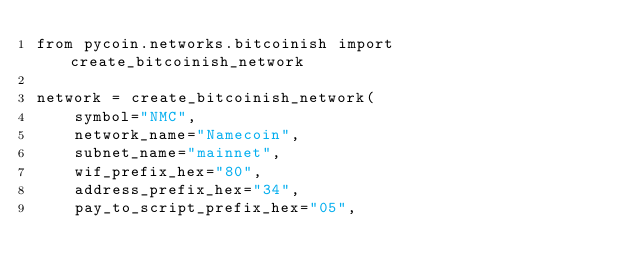<code> <loc_0><loc_0><loc_500><loc_500><_Python_>from pycoin.networks.bitcoinish import create_bitcoinish_network

network = create_bitcoinish_network(
    symbol="NMC",
    network_name="Namecoin",
    subnet_name="mainnet",
    wif_prefix_hex="80",
    address_prefix_hex="34",
    pay_to_script_prefix_hex="05",</code> 